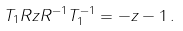Convert formula to latex. <formula><loc_0><loc_0><loc_500><loc_500>T _ { 1 } R z R ^ { - 1 } T _ { 1 } ^ { - 1 } = - z - 1 \, .</formula> 